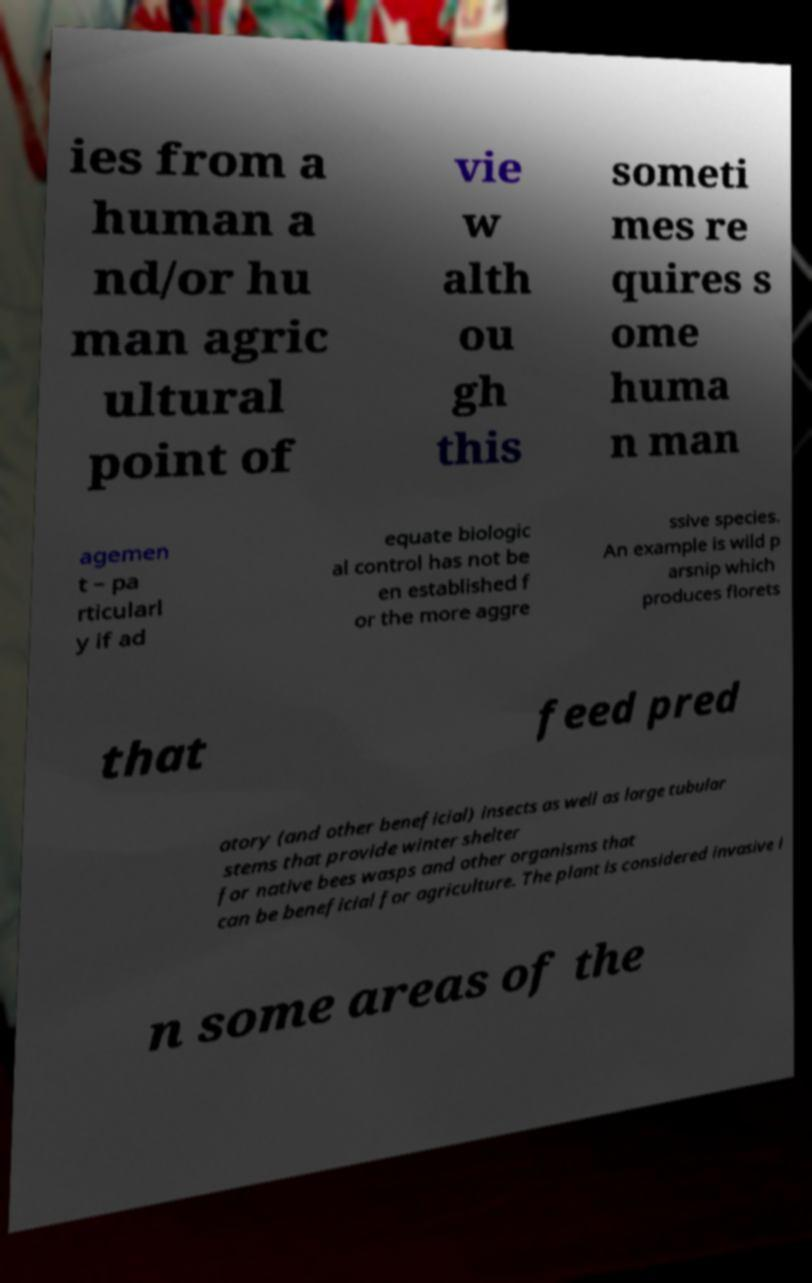There's text embedded in this image that I need extracted. Can you transcribe it verbatim? ies from a human a nd/or hu man agric ultural point of vie w alth ou gh this someti mes re quires s ome huma n man agemen t – pa rticularl y if ad equate biologic al control has not be en established f or the more aggre ssive species. An example is wild p arsnip which produces florets that feed pred atory (and other beneficial) insects as well as large tubular stems that provide winter shelter for native bees wasps and other organisms that can be beneficial for agriculture. The plant is considered invasive i n some areas of the 